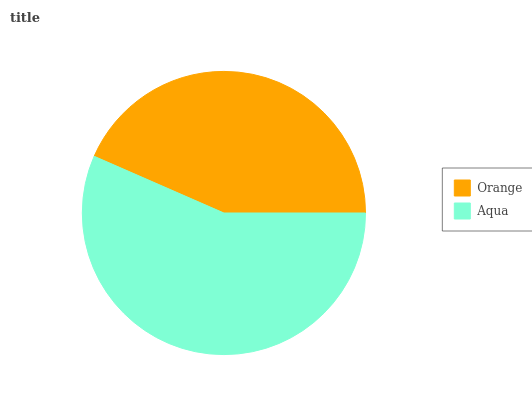Is Orange the minimum?
Answer yes or no. Yes. Is Aqua the maximum?
Answer yes or no. Yes. Is Aqua the minimum?
Answer yes or no. No. Is Aqua greater than Orange?
Answer yes or no. Yes. Is Orange less than Aqua?
Answer yes or no. Yes. Is Orange greater than Aqua?
Answer yes or no. No. Is Aqua less than Orange?
Answer yes or no. No. Is Aqua the high median?
Answer yes or no. Yes. Is Orange the low median?
Answer yes or no. Yes. Is Orange the high median?
Answer yes or no. No. Is Aqua the low median?
Answer yes or no. No. 